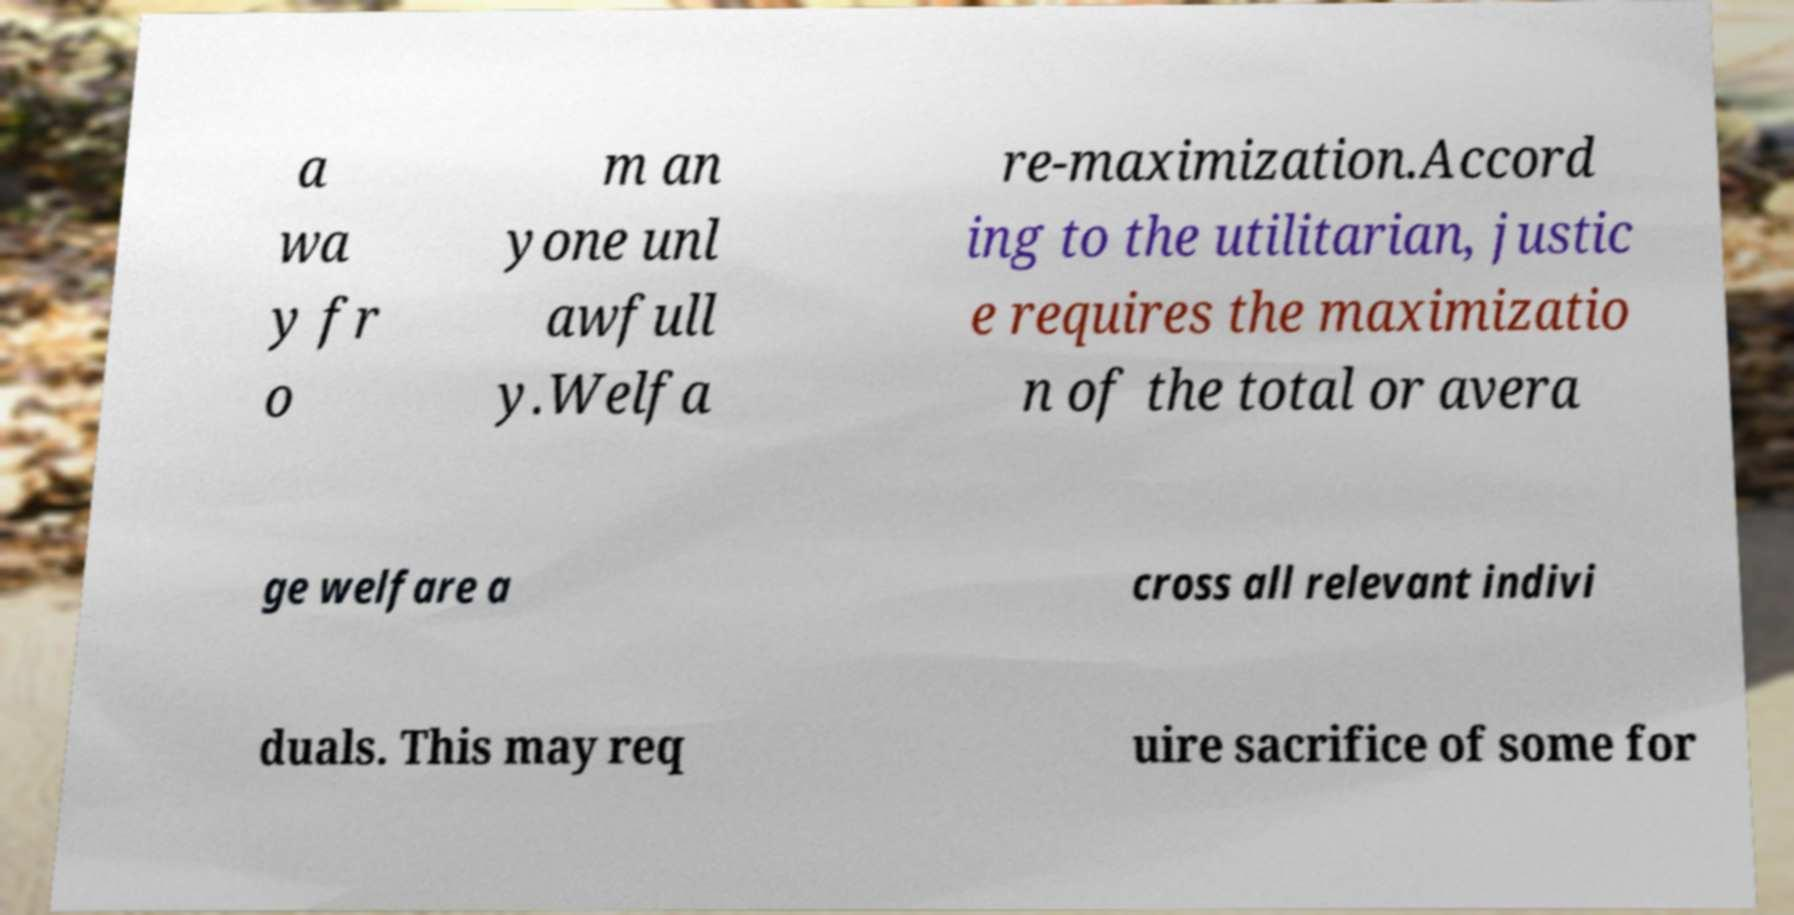Could you extract and type out the text from this image? a wa y fr o m an yone unl awfull y.Welfa re-maximization.Accord ing to the utilitarian, justic e requires the maximizatio n of the total or avera ge welfare a cross all relevant indivi duals. This may req uire sacrifice of some for 